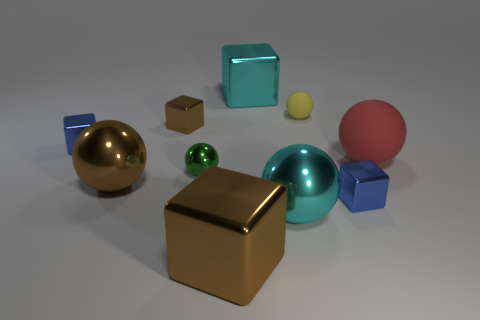Subtract all small blue metal cubes. How many cubes are left? 3 Subtract all yellow spheres. How many brown blocks are left? 2 Subtract all yellow balls. How many balls are left? 4 Subtract 4 blocks. How many blocks are left? 1 Add 2 big yellow cylinders. How many big yellow cylinders exist? 2 Subtract 1 brown spheres. How many objects are left? 9 Subtract all blue blocks. Subtract all cyan spheres. How many blocks are left? 3 Subtract all big red objects. Subtract all tiny metal blocks. How many objects are left? 6 Add 4 big cyan things. How many big cyan things are left? 6 